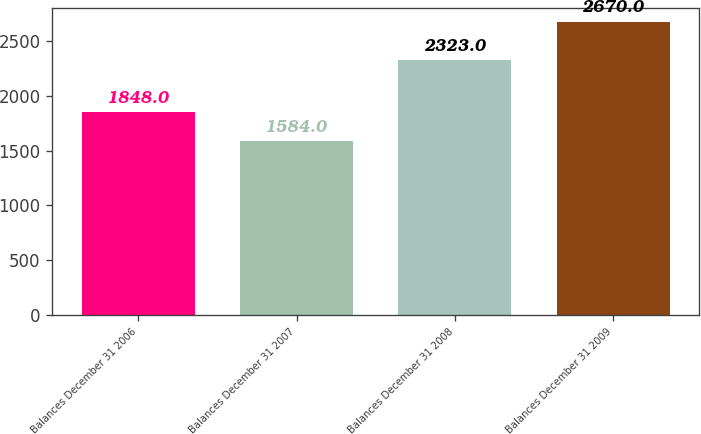Convert chart to OTSL. <chart><loc_0><loc_0><loc_500><loc_500><bar_chart><fcel>Balances December 31 2006<fcel>Balances December 31 2007<fcel>Balances December 31 2008<fcel>Balances December 31 2009<nl><fcel>1848<fcel>1584<fcel>2323<fcel>2670<nl></chart> 